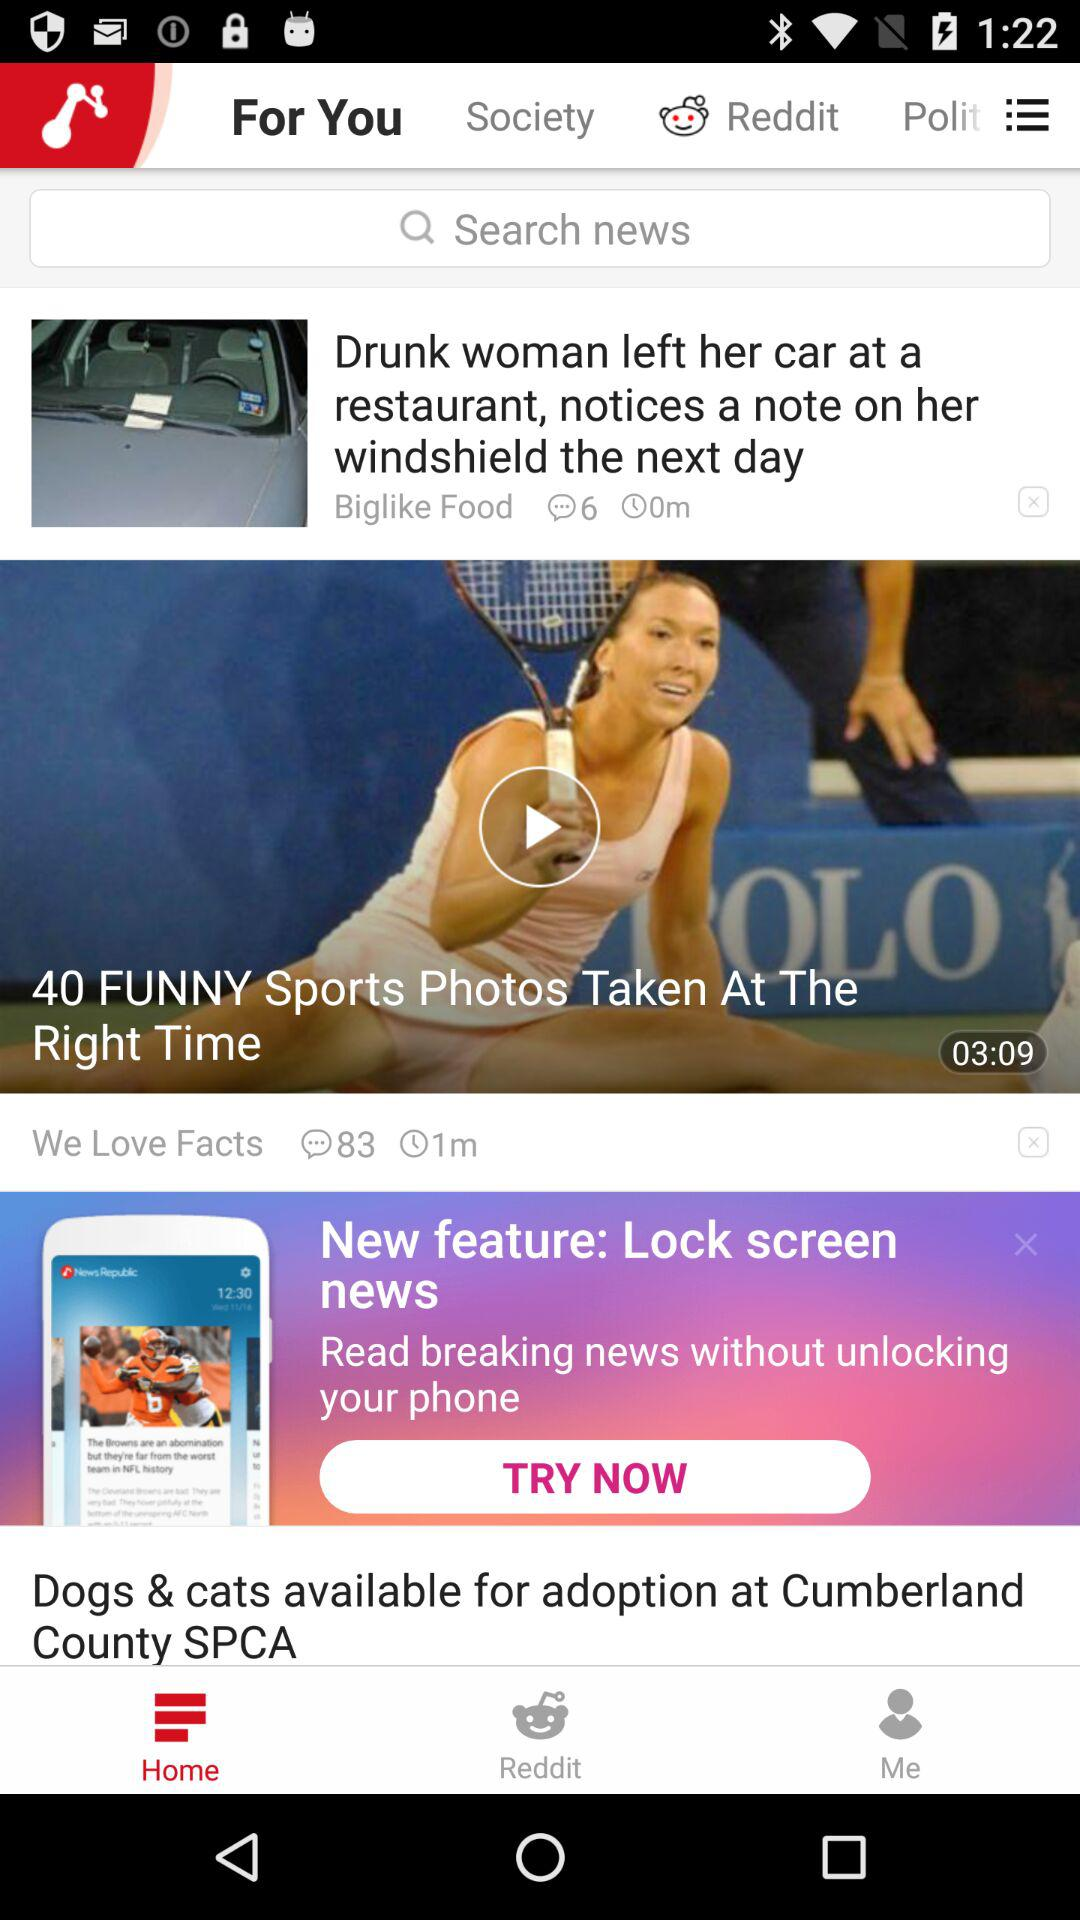Which option is selected in the taskbar? The selected option is "Home". 